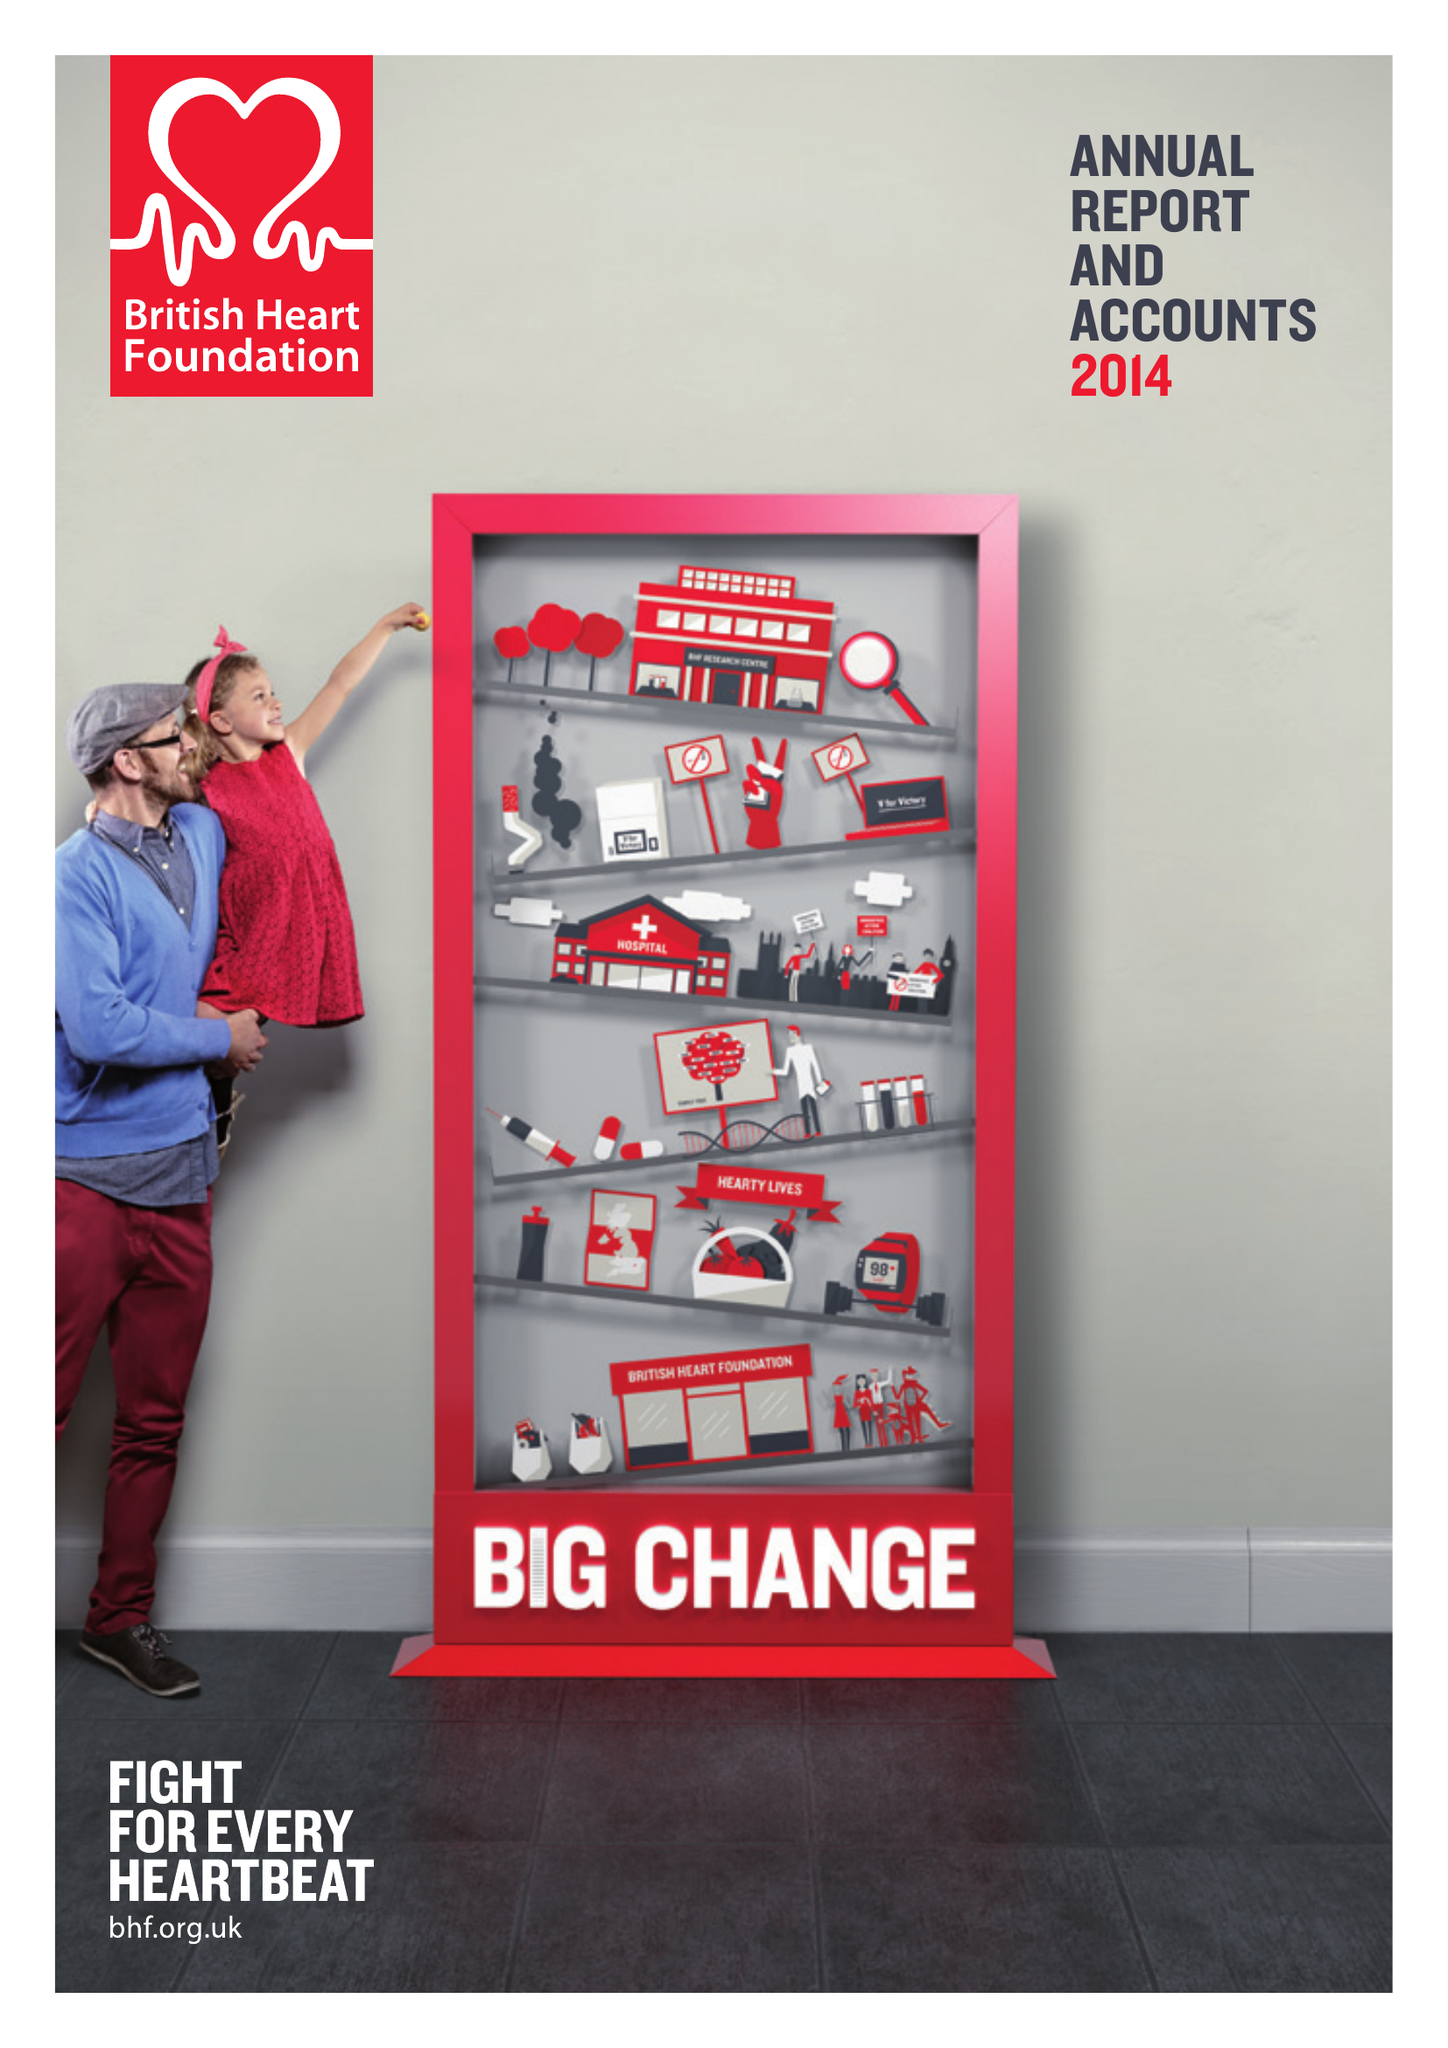What is the value for the address__street_line?
Answer the question using a single word or phrase. 180 HAMPSTEAD ROAD 